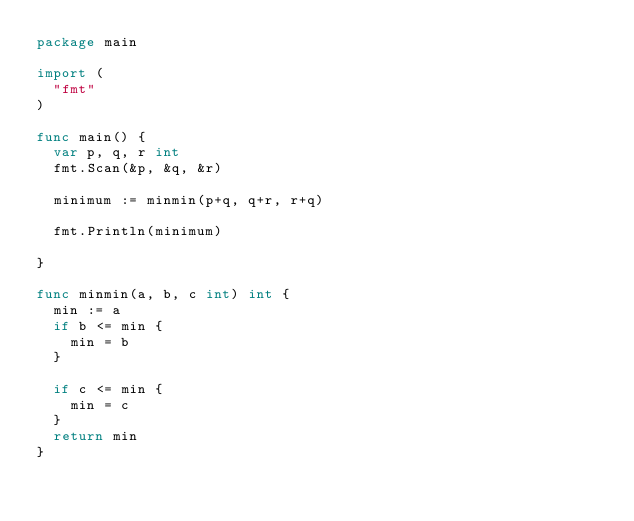Convert code to text. <code><loc_0><loc_0><loc_500><loc_500><_Go_>package main

import (
	"fmt"
)

func main() {
	var p, q, r int
	fmt.Scan(&p, &q, &r)

	minimum := minmin(p+q, q+r, r+q)

	fmt.Println(minimum)

}

func minmin(a, b, c int) int {
	min := a
	if b <= min {
		min = b
	}

	if c <= min {
		min = c
	}
	return min
}
</code> 